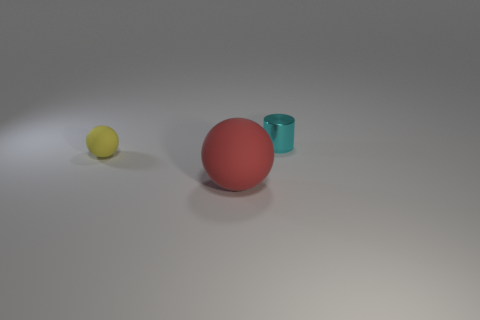What can you infer about the lighting and setting in which these objects are placed? The lighting in the image is soft and diffused, creating gentle shadows to the side of each object. This suggests an indoor setting with possibly an overhead light source. The background is a neutral grey, which gives the impression of a controlled environment, perhaps a photographic studio or a simple setup designed to focus attention on the objects themselves. 